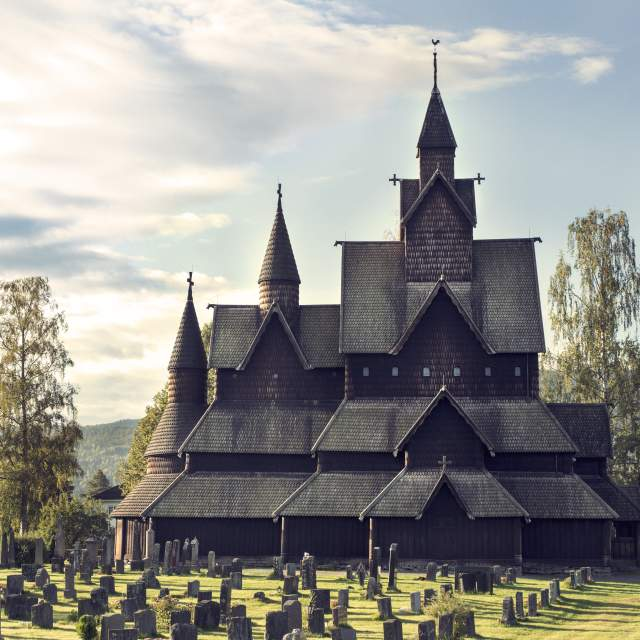Can you tell me more about the historical significance of this church? Heddal Stave Church, built in the early 13th century, is the largest of Norway's remaining stave churches and a masterpiece of medieval wooden architecture. The church is not only a place of worship but also a monument of cultural heritage, reflecting the craftsmanship and artistry of the period. Over the centuries, it has withstood numerous restorations and remains a symbol of Norway’s rich medieval history. The church is adorned with intricate carvings and wooden motifs, some of which depict scenes from Norse mythology, providing a glimpse into the life and beliefs of the people from that era. 